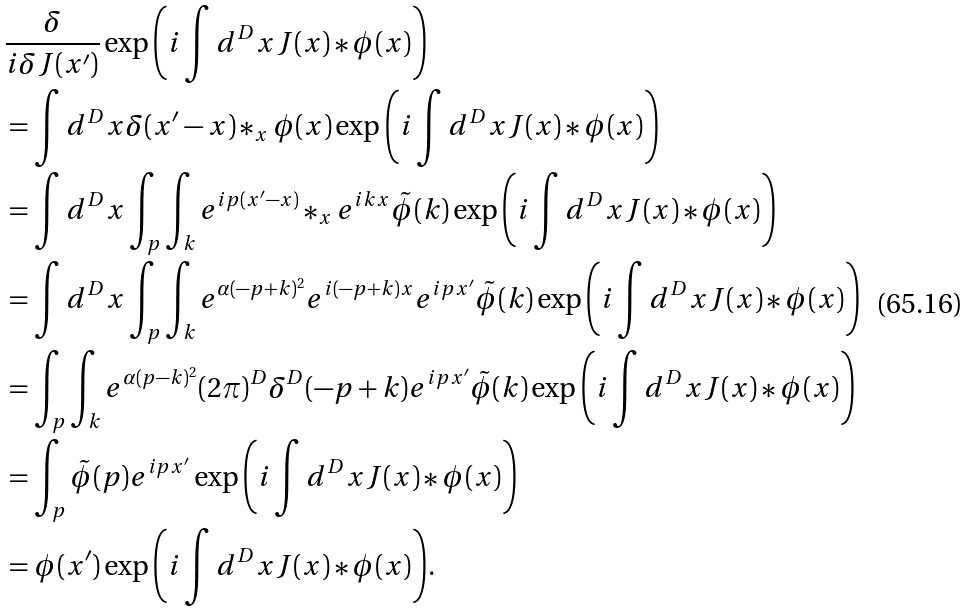Convert formula to latex. <formula><loc_0><loc_0><loc_500><loc_500>& \frac { \delta } { i \delta J ( x ^ { \prime } ) } \exp { \left ( i \int d ^ { D } x J ( x ) \ast \phi ( x ) \right ) } \\ & = \int d ^ { D } x \delta ( x ^ { \prime } - x ) \ast _ { x } \phi ( x ) \exp { \left ( i \int d ^ { D } x J ( x ) \ast \phi ( x ) \right ) } \\ & = \int d ^ { D } x \int _ { p } \int _ { k } e ^ { i p ( x ^ { \prime } - x ) } \ast _ { x } e ^ { i k x } \tilde { \phi } ( k ) \exp { \left ( i \int d ^ { D } x J ( x ) \ast \phi ( x ) \right ) } \\ & = \int d ^ { D } x \int _ { p } \int _ { k } e ^ { \alpha ( - p + k ) ^ { 2 } } e ^ { i ( - p + k ) x } e ^ { i p x ^ { \prime } } \tilde { \phi } ( k ) \exp { \left ( i \int d ^ { D } x J ( x ) \ast \phi ( x ) \right ) } \\ & = \int _ { p } \int _ { k } e ^ { \alpha ( p - k ) ^ { 2 } } ( 2 \pi ) ^ { D } \delta ^ { D } ( - p + k ) e ^ { i p x ^ { \prime } } \tilde { \phi } ( k ) \exp { \left ( i \int d ^ { D } x J ( x ) \ast \phi ( x ) \right ) } \\ & = \int _ { p } \tilde { \phi } ( p ) e ^ { i p x ^ { \prime } } \exp { \left ( i \int d ^ { D } x J ( x ) \ast \phi ( x ) \right ) } \\ & = \phi ( x ^ { \prime } ) \exp { \left ( i \int d ^ { D } x J ( x ) \ast \phi ( x ) \right ) } .</formula> 